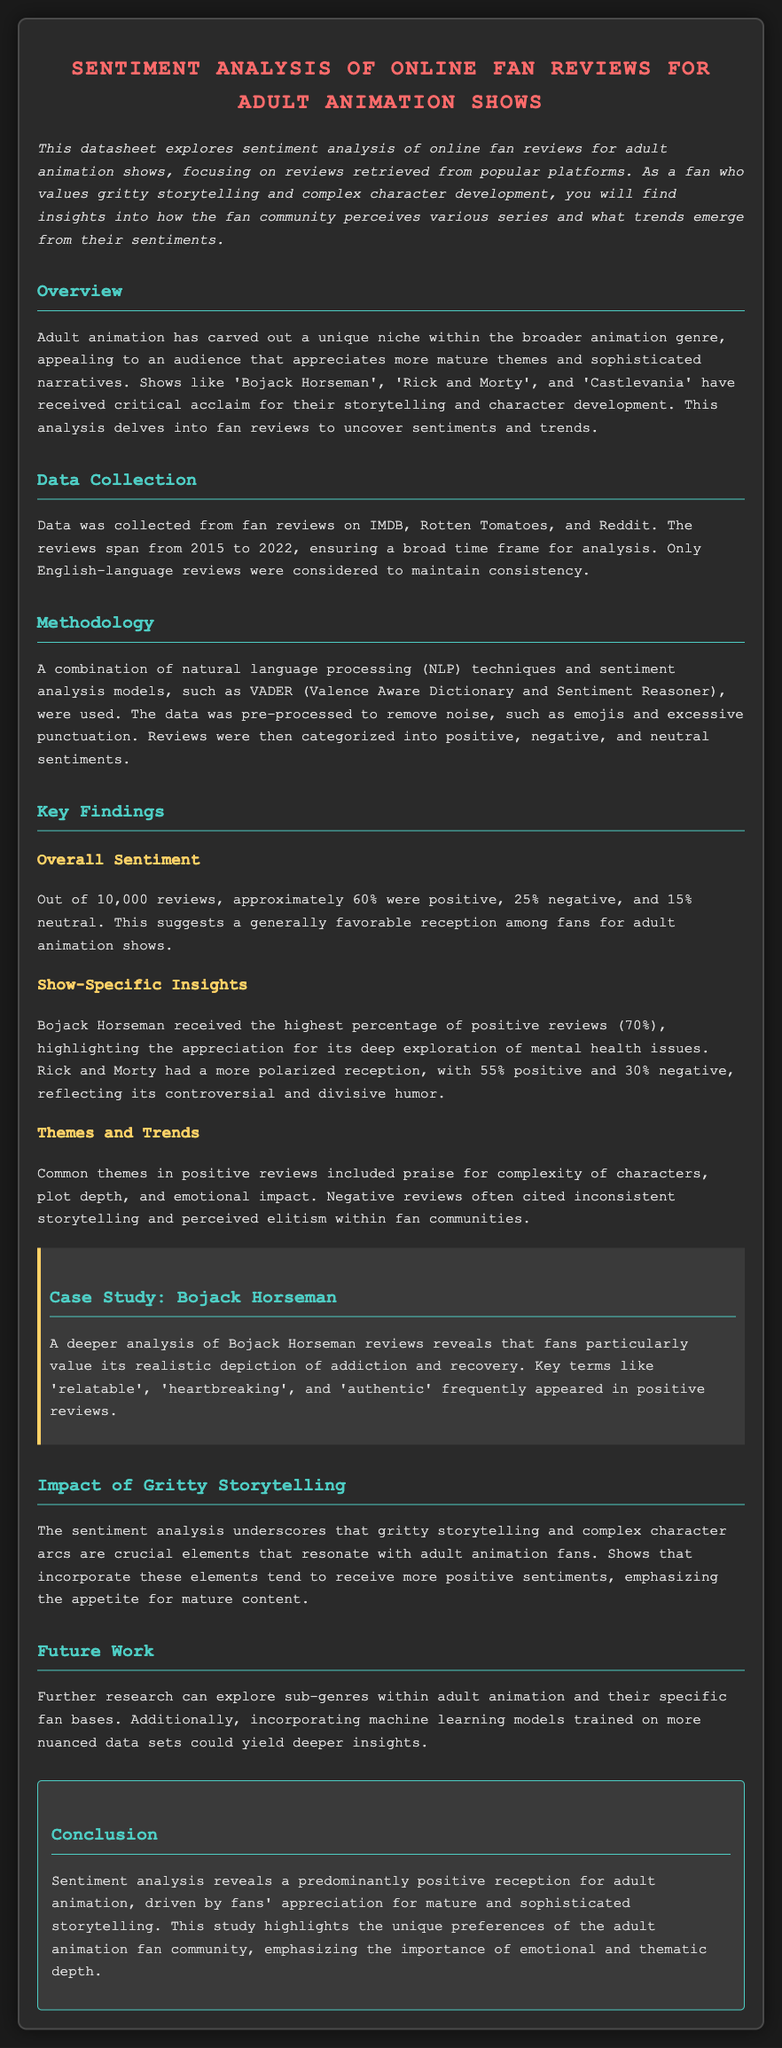What percentage of reviews were positive? The document states that approximately 60% of the reviews were positive.
Answer: 60% Which show received the highest percentage of positive reviews? The document indicates that Bojack Horseman received the highest percentage of positive reviews at 70%.
Answer: Bojack Horseman What years does the data collection span? The document specifies that data was collected from reviews spanning from 2015 to 2022.
Answer: 2015 to 2022 What sentiment analysis model was used in this study? The document mentions the VADER (Valence Aware Dictionary and Sentiment Reasoner) model as the sentiment analysis model used.
Answer: VADER What themes were common in positive reviews? The document lists complexity of characters, plot depth, and emotional impact as common themes in positive reviews.
Answer: Complexity of characters, plot depth, emotional impact How did Rick and Morty’s reviews compare? The document describes Rick and Morty's reception as more polarized, with 55% positive and 30% negative.
Answer: Polarized reception, 55% positive, 30% negative What key terms frequently appeared in positive reviews of Bojack Horseman? The document notes that terms like 'relatable', 'heartbreaking', and 'authentic' appeared frequently in positive reviews.
Answer: Relatable, heartbreaking, authentic What is the future work suggested in the analysis? The document suggests exploring sub-genres within adult animation and incorporating machine learning models for deeper insights.
Answer: Exploring sub-genres and incorporating machine learning models 